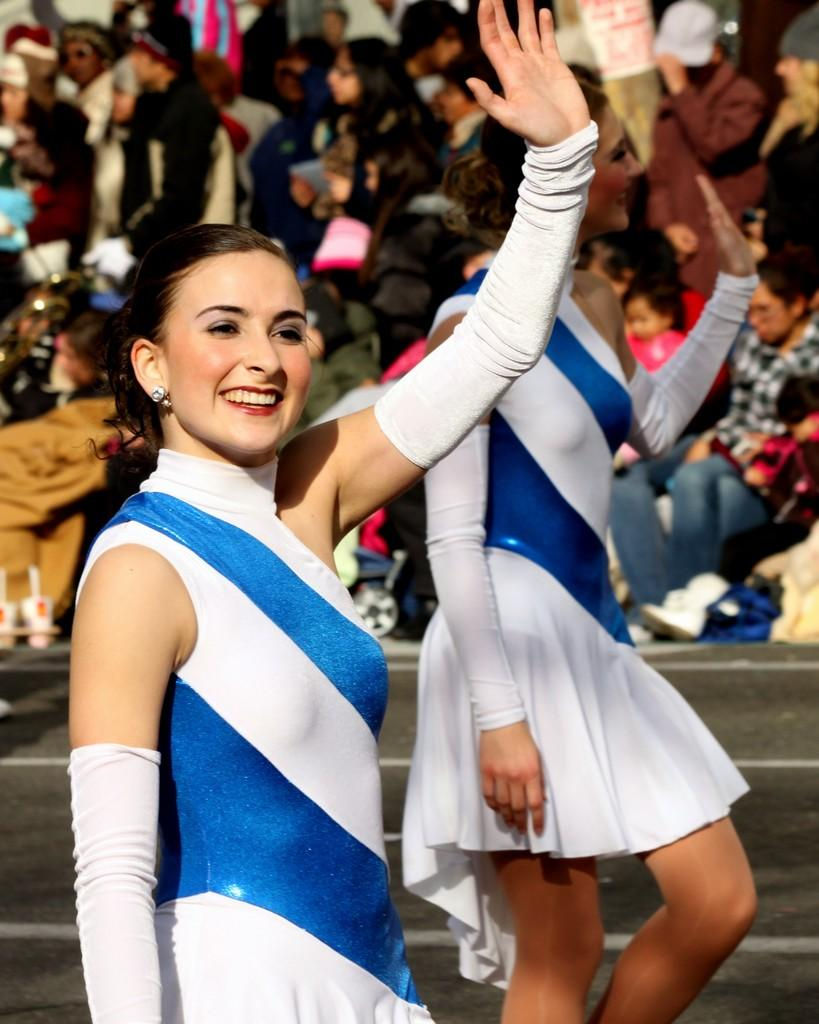How many women are in the foreground of the image? There are two women visible in the foreground of the image. What is the setting of the image? The women are on a road in the image. What can be seen in the background of the image? There is a crowd visible in the background of the image. What type of jeans are the women wearing in the image? There is no information about the women's clothing in the image, so we cannot determine if they are wearing jeans or any other type of clothing. What yard is visible in the image? There is no yard visible in the image; the women are on a road. 